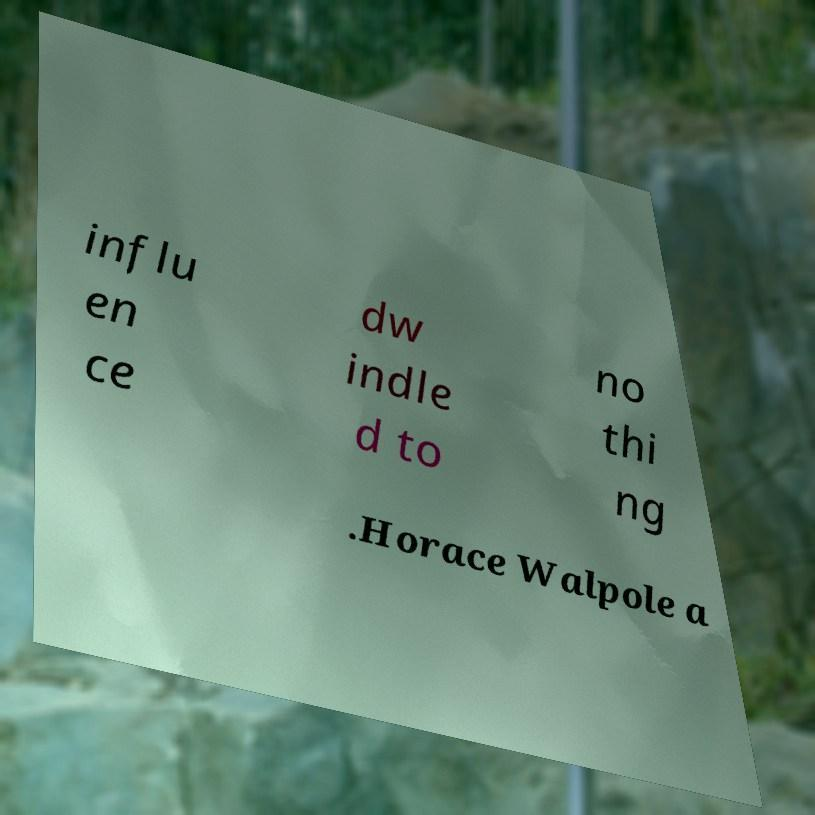There's text embedded in this image that I need extracted. Can you transcribe it verbatim? influ en ce dw indle d to no thi ng .Horace Walpole a 